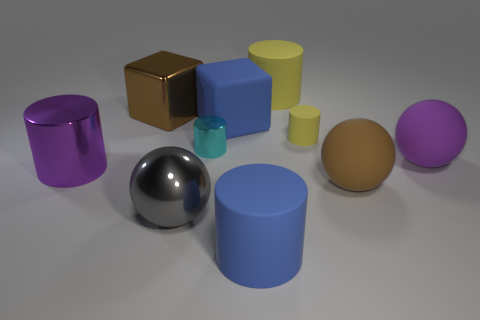Subtract all cyan cylinders. How many cylinders are left? 4 Subtract all big blue cylinders. How many cylinders are left? 4 Subtract all purple balls. Subtract all cyan cylinders. How many balls are left? 2 Subtract all cubes. How many objects are left? 8 Add 5 big brown matte balls. How many big brown matte balls are left? 6 Add 5 cylinders. How many cylinders exist? 10 Subtract 0 red cylinders. How many objects are left? 10 Subtract all large brown rubber objects. Subtract all gray things. How many objects are left? 8 